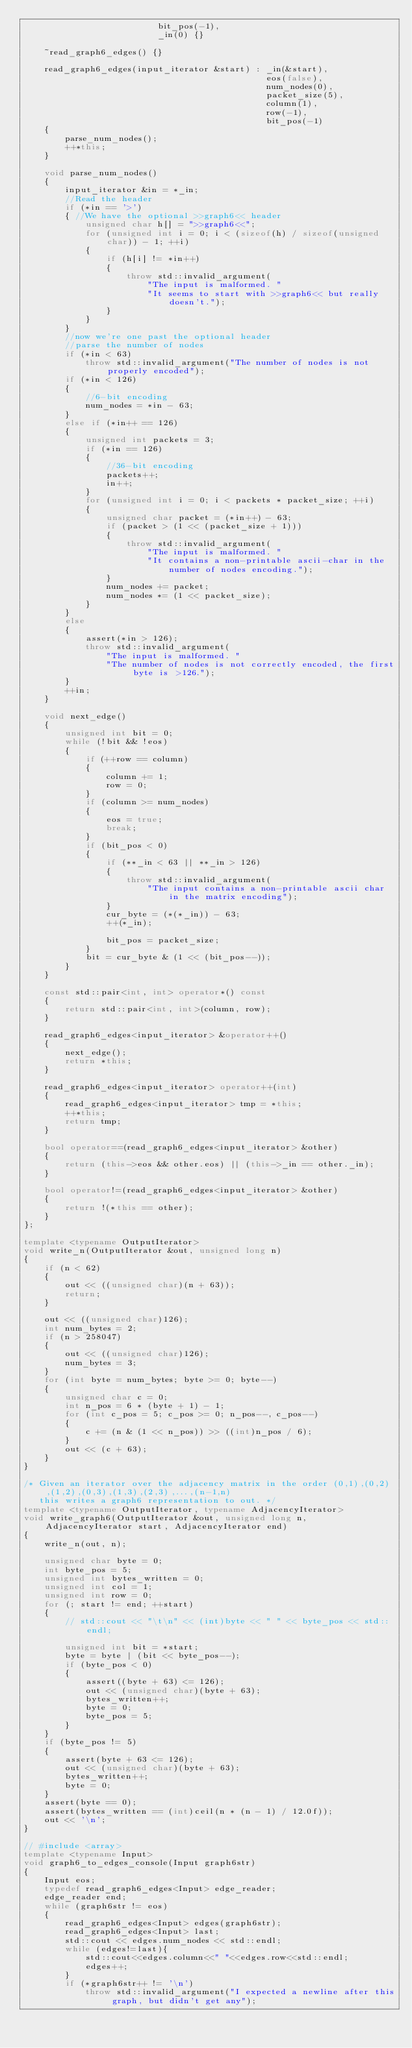<code> <loc_0><loc_0><loc_500><loc_500><_C++_>                          bit_pos(-1),
                          _in(0) {}

    ~read_graph6_edges() {}

    read_graph6_edges(input_iterator &start) : _in(&start),
                                               eos(false),
                                               num_nodes(0),
                                               packet_size(5),
                                               column(1),
                                               row(-1),
                                               bit_pos(-1)
    {
        parse_num_nodes();
        ++*this;
    }

    void parse_num_nodes()
    {
        input_iterator &in = *_in;
        //Read the header
        if (*in == '>')
        { //We have the optional >>graph6<< header
            unsigned char h[] = ">>graph6<<";
            for (unsigned int i = 0; i < (sizeof(h) / sizeof(unsigned char)) - 1; ++i)
            {
                if (h[i] != *in++)
                {
                    throw std::invalid_argument(
                        "The input is malformed. "
                        "It seems to start with >>graph6<< but really doesn't.");
                }
            }
        }
        //now we're one past the optional header
        //parse the number of nodes
        if (*in < 63)
            throw std::invalid_argument("The number of nodes is not properly encoded");
        if (*in < 126)
        {
            //6-bit encoding
            num_nodes = *in - 63;
        }
        else if (*in++ == 126)
        {
            unsigned int packets = 3;
            if (*in == 126)
            {
                //36-bit encoding
                packets++;
                in++;
            }
            for (unsigned int i = 0; i < packets * packet_size; ++i)
            {
                unsigned char packet = (*in++) - 63;
                if (packet > (1 << (packet_size + 1)))
                {
                    throw std::invalid_argument(
                        "The input is malformed. "
                        "It contains a non-printable ascii-char in the number of nodes encoding.");
                }
                num_nodes += packet;
                num_nodes *= (1 << packet_size);
            }
        }
        else
        {
            assert(*in > 126);
            throw std::invalid_argument(
                "The input is malformed. "
                "The number of nodes is not correctly encoded, the first byte is >126.");
        }
        ++in;
    }

    void next_edge()
    {
        unsigned int bit = 0;
        while (!bit && !eos)
        {
            if (++row == column)
            {
                column += 1;
                row = 0;
            }
            if (column >= num_nodes)
            {
                eos = true;
                break;
            }
            if (bit_pos < 0)
            {
                if (**_in < 63 || **_in > 126)
                {
                    throw std::invalid_argument(
                        "The input contains a non-printable ascii char in the matrix encoding");
                }
                cur_byte = (*(*_in)) - 63;
                ++(*_in);

                bit_pos = packet_size;
            }
            bit = cur_byte & (1 << (bit_pos--));
        }
    }

    const std::pair<int, int> operator*() const
    {
        return std::pair<int, int>(column, row);
    }

    read_graph6_edges<input_iterator> &operator++()
    {
        next_edge();
        return *this;
    }

    read_graph6_edges<input_iterator> operator++(int)
    {
        read_graph6_edges<input_iterator> tmp = *this;
        ++*this;
        return tmp;
    }

    bool operator==(read_graph6_edges<input_iterator> &other)
    {
        return (this->eos && other.eos) || (this->_in == other._in);
    }

    bool operator!=(read_graph6_edges<input_iterator> &other)
    {
        return !(*this == other);
    }
};

template <typename OutputIterator>
void write_n(OutputIterator &out, unsigned long n)
{
    if (n < 62)
    {
        out << ((unsigned char)(n + 63));
        return;
    }

    out << ((unsigned char)126);
    int num_bytes = 2;
    if (n > 258047)
    {
        out << ((unsigned char)126);
        num_bytes = 3;
    }
    for (int byte = num_bytes; byte >= 0; byte--)
    {
        unsigned char c = 0;
        int n_pos = 6 * (byte + 1) - 1;
        for (int c_pos = 5; c_pos >= 0; n_pos--, c_pos--)
        {
            c += (n & (1 << n_pos)) >> ((int)n_pos / 6);
        }
        out << (c + 63);
    }
}

/* Given an iterator over the adjacency matrix in the order (0,1),(0,2),(1,2),(0,3),(1,3),(2,3),...,(n-1,n)
   this writes a graph6 representation to out. */
template <typename OutputIterator, typename AdjacencyIterator>
void write_graph6(OutputIterator &out, unsigned long n, AdjacencyIterator start, AdjacencyIterator end)
{
    write_n(out, n);

    unsigned char byte = 0;
    int byte_pos = 5;
    unsigned int bytes_written = 0;
    unsigned int col = 1;
    unsigned int row = 0;
    for (; start != end; ++start)
    {
        // std::cout << "\t\n" << (int)byte << " " << byte_pos << std::endl;

        unsigned int bit = *start;
        byte = byte | (bit << byte_pos--);
        if (byte_pos < 0)
        {
            assert((byte + 63) <= 126);
            out << (unsigned char)(byte + 63);
            bytes_written++;
            byte = 0;
            byte_pos = 5;
        }
    }
    if (byte_pos != 5)
    {
        assert(byte + 63 <= 126);
        out << (unsigned char)(byte + 63);
        bytes_written++;
        byte = 0;
    }
    assert(byte == 0);
    assert(bytes_written == (int)ceil(n * (n - 1) / 12.0f));
    out << '\n';
}

// #include <array>
template <typename Input>
void graph6_to_edges_console(Input graph6str)
{
    Input eos;
    typedef read_graph6_edges<Input> edge_reader;
    edge_reader end;
    while (graph6str != eos)
    {
        read_graph6_edges<Input> edges(graph6str);
        read_graph6_edges<Input> last;
        std::cout << edges.num_nodes << std::endl;
        while (edges!=last){
            std::cout<<edges.column<<" "<<edges.row<<std::endl;
            edges++;
        }
        if (*graph6str++ != '\n')
            throw std::invalid_argument("I expected a newline after this graph, but didn't get any");</code> 